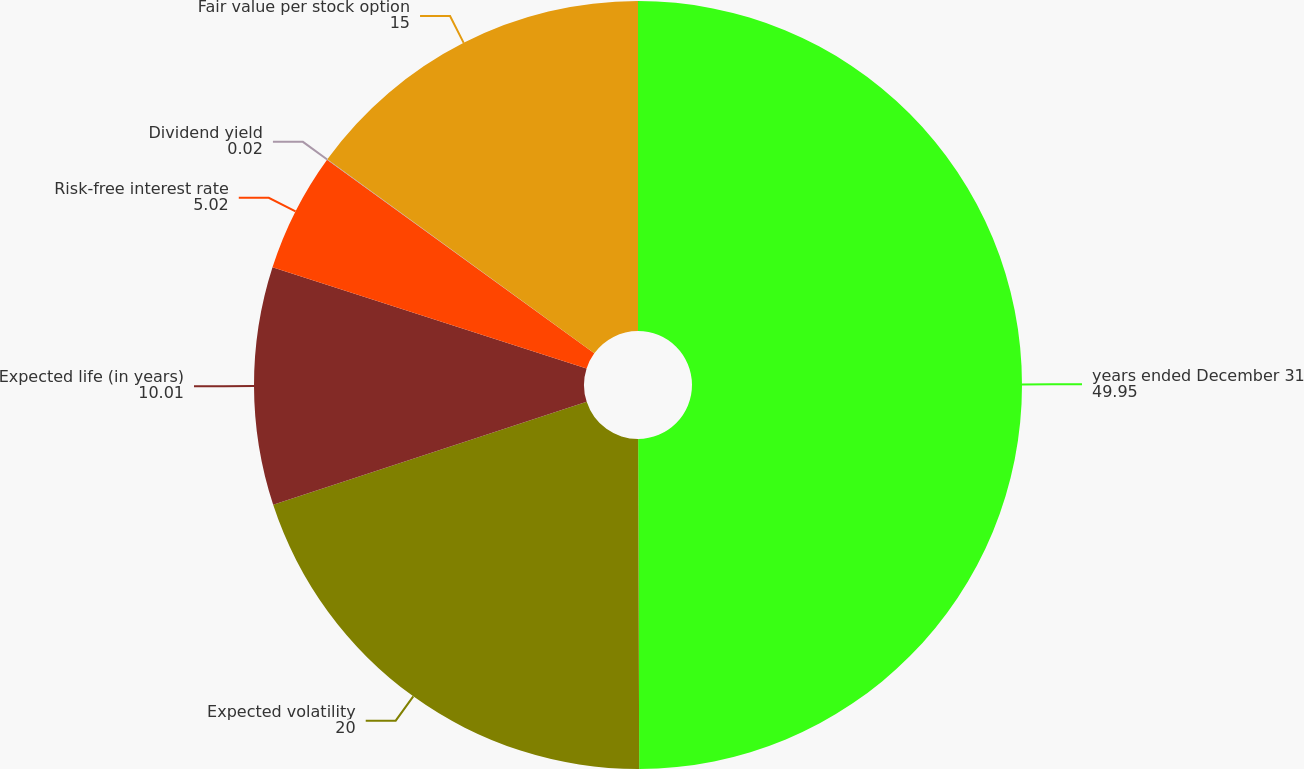Convert chart to OTSL. <chart><loc_0><loc_0><loc_500><loc_500><pie_chart><fcel>years ended December 31<fcel>Expected volatility<fcel>Expected life (in years)<fcel>Risk-free interest rate<fcel>Dividend yield<fcel>Fair value per stock option<nl><fcel>49.95%<fcel>20.0%<fcel>10.01%<fcel>5.02%<fcel>0.02%<fcel>15.0%<nl></chart> 